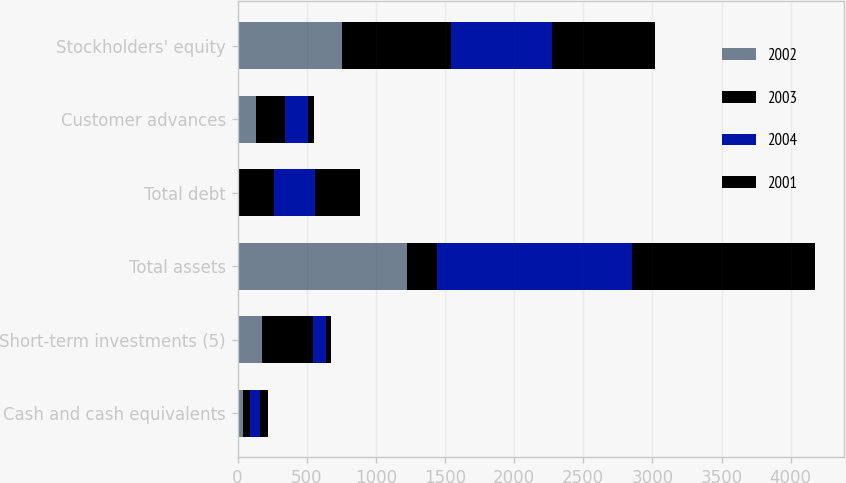<chart> <loc_0><loc_0><loc_500><loc_500><stacked_bar_chart><ecel><fcel>Cash and cash equivalents<fcel>Short-term investments (5)<fcel>Total assets<fcel>Total debt<fcel>Customer advances<fcel>Stockholders' equity<nl><fcel>2002<fcel>37.4<fcel>179.3<fcel>1228.1<fcel>4.2<fcel>131.6<fcel>755.9<nl><fcel>2003<fcel>50<fcel>369.3<fcel>211.5<fcel>258.8<fcel>211.5<fcel>787.3<nl><fcel>2004<fcel>77.2<fcel>91.7<fcel>1415.6<fcel>293.5<fcel>166<fcel>733.5<nl><fcel>2001<fcel>56.5<fcel>38.4<fcel>1321.7<fcel>326.2<fcel>40<fcel>740.9<nl></chart> 